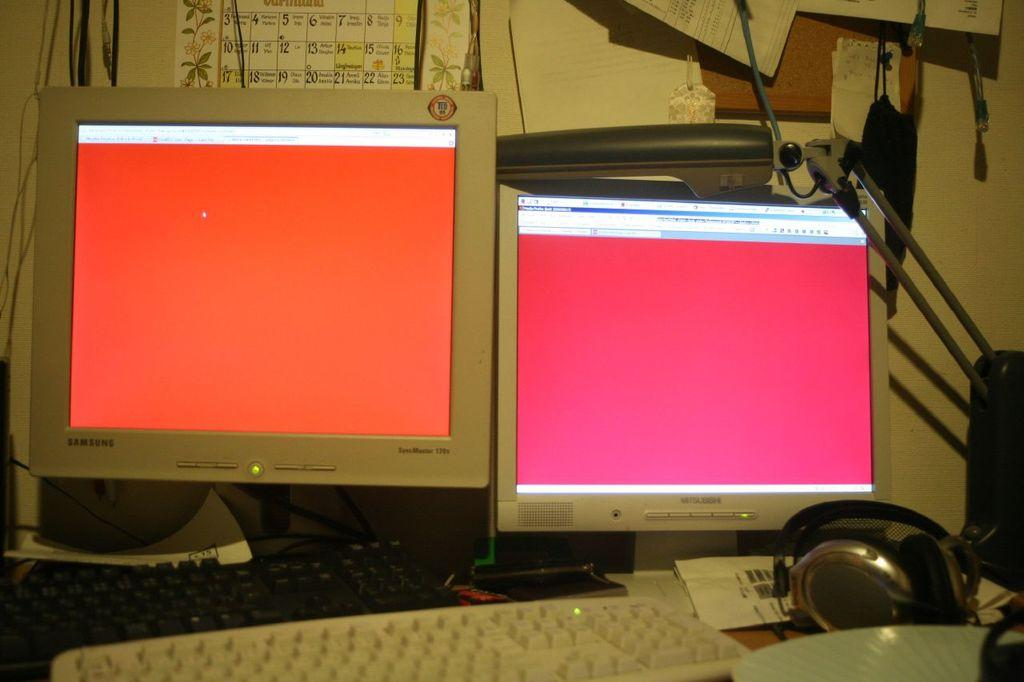<image>
Summarize the visual content of the image. Two computer monitors side-by-side, one is Samsung, the other is Mitsubishi. 